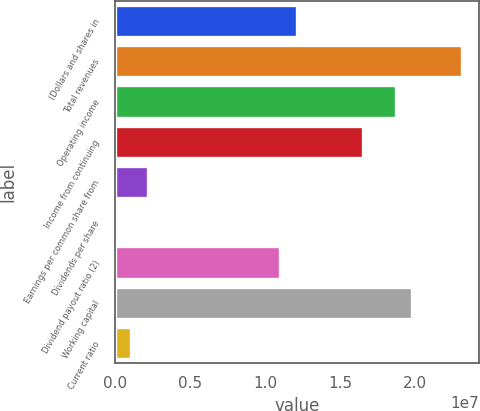Convert chart. <chart><loc_0><loc_0><loc_500><loc_500><bar_chart><fcel>(Dollars and shares in<fcel>Total revenues<fcel>Operating income<fcel>Income from continuing<fcel>Earnings per common share from<fcel>Dividends per share<fcel>Dividend payout ratio (2)<fcel>Working capital<fcel>Current ratio<nl><fcel>1.2096e+07<fcel>2.30924e+07<fcel>1.86939e+07<fcel>1.64946e+07<fcel>2.19928e+06<fcel>1.33<fcel>1.09964e+07<fcel>1.97935e+07<fcel>1.09964e+06<nl></chart> 